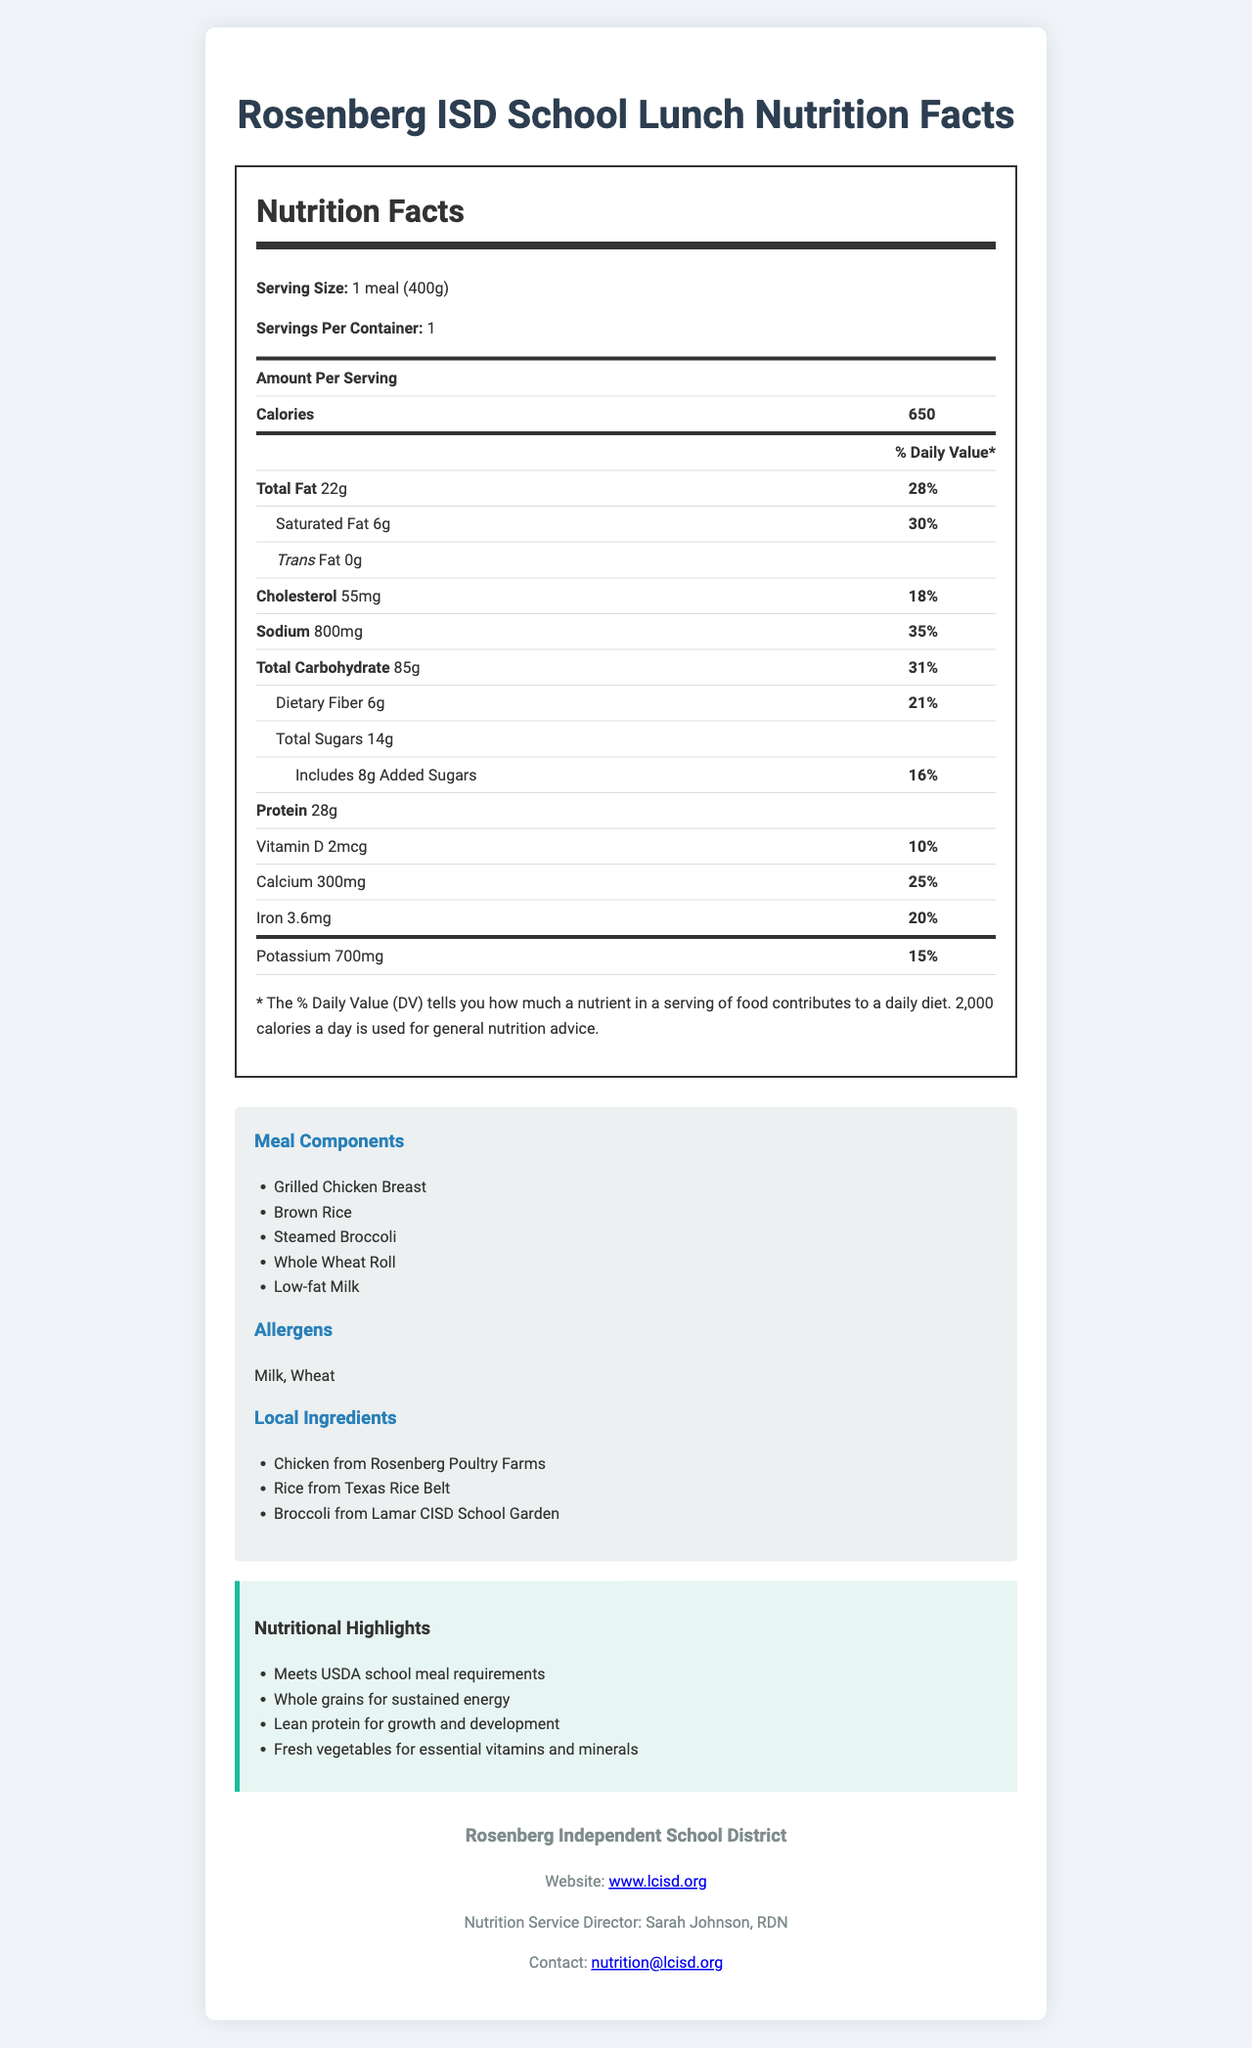What is the serving size of the school lunch meal? The serving size is displayed under the "Nutrition Facts" heading in the upper part of the document.
Answer: 1 meal (400g) How many servings are there per container? The number of servings per container is also listed under the "Nutrition Facts" heading.
Answer: 1 What is the total fat content in the meal? The total fat content is listed under the "Amount Per Serving" section of the Nutrition Facts.
Answer: 22g Who is the Nutrition Service Director for Rosenberg Independent School District? The Nutrition Service Director's name is provided in the "school-info" section at the bottom of the document.
Answer: Sarah Johnson, RDN Which local ingredient supplies the rice for the school lunch? The local ingredient suppliers are listed in the “Local Ingredients” section.
Answer: Texas Rice Belt What is the percentage of Daily Value for sodium in the meal? This information is found next to the sodium amount in the Nutrition Facts table.
Answer: 35% Which of the following allergens are present in the meal? A. Milk B. Wheat C. Soy D. A and B The allergens listed are "Milk" and "Wheat," found in the "Allergens" section.
Answer: D. A and B What is the main course item in this meal? A. Grilled Chicken Breast B. Brown Rice C. Whole Wheat Roll D. Low-fat Milk The main course item, "Grilled Chicken Breast," is listed in the "Meal Components" section.
Answer: A. Grilled Chicken Breast True or False: The meal contains trans fat. It is mentioned in the Nutrition Facts table that the meal contains 0g of trans fat.
Answer: False Describe the nutritional highlights of the meal. The nutritional highlights are directly listed in the "Nutritional Highlights" section of the document.
Answer: The meal meets USDA school meal requirements, includes whole grains for sustained energy, provides lean protein for growth and development, and offers fresh vegetables for essential vitamins and minerals. What is the average cost per meal in the Rosenberg ISD cafeteria? The document does not provide any information regarding the cost of the meal.
Answer: Cannot be determined What is the total carbohydrate content, excluding dietary fiber and added sugars? The total carbohydrate content is 85g, dietary fiber is 6g, and added sugars are 8g, making the remaining carbohydrate content 71g (85g - 6g - 8g).
Answer: 71g Is the meal compliant with USDA school meal requirements? It is explicitly stated under the "Nutritional Highlights" section.
Answer: Yes 